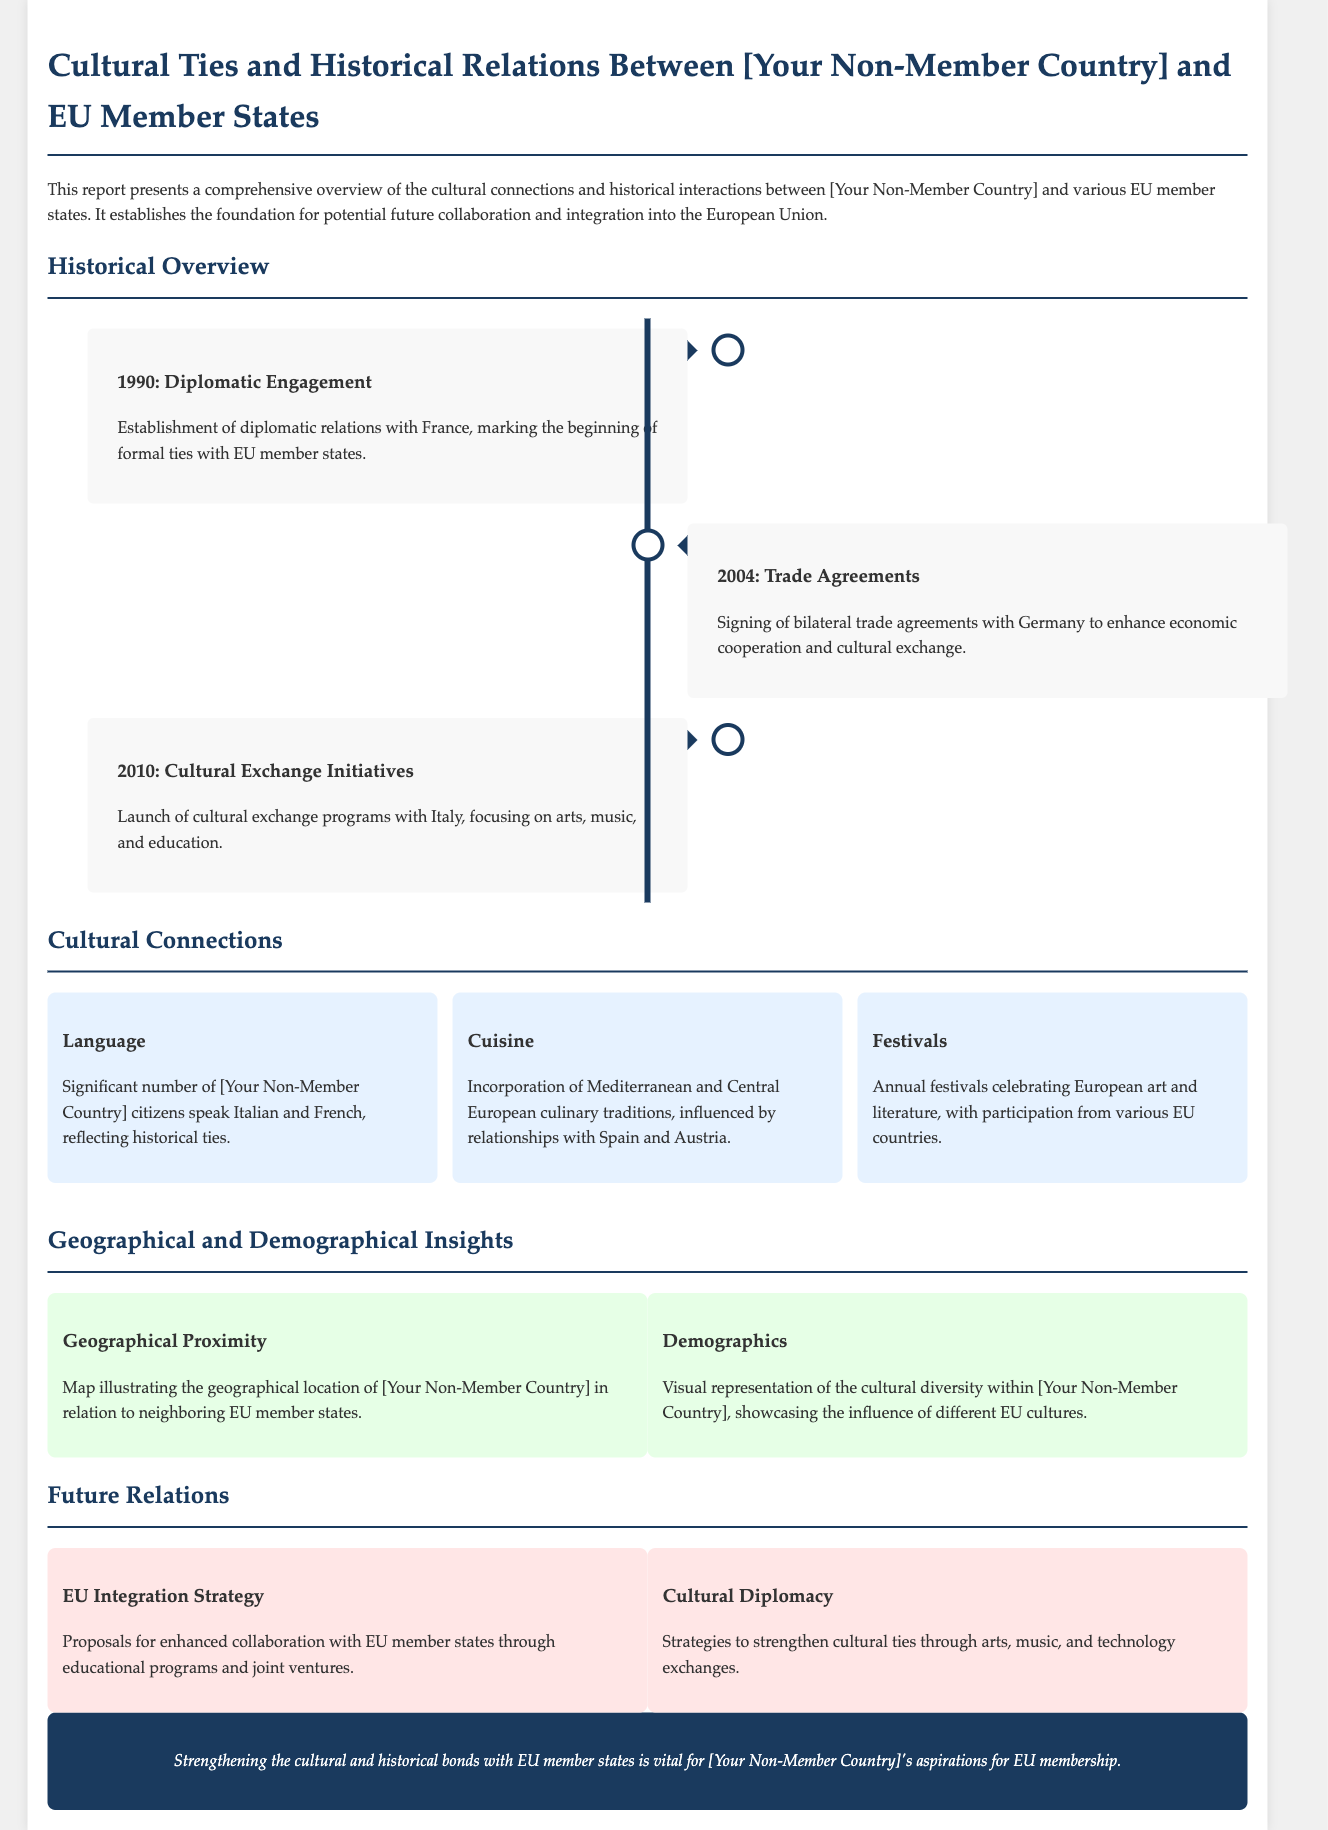What year did diplomatic relations with France begin? The report states that the establishment of diplomatic relations with France occurred in 1990.
Answer: 1990 Which country was involved in the 2004 trade agreements? The document mentions that bilateral trade agreements were signed with Germany in 2004.
Answer: Germany What cultural exchange programs were launched in 2010? The report describes the launch of cultural exchange programs with Italy focusing on arts, music, and education.
Answer: Italy How many cultural connections are highlighted in the document? The document lists three cultural connections: Language, Cuisine, and Festivals.
Answer: Three What is one type of future relation proposed for EU integration? The report suggests enhancing collaboration through educational programs as part of the EU integration strategy.
Answer: Educational programs What influence is seen in the cuisine of the non-member country? The document notes the incorporation of Mediterranean and Central European culinary traditions, influenced by Spain and Austria.
Answer: Spain and Austria What color is used for the conclusion section? The conclusion section is styled with a background color of dark blue indicated by the color code used in the CSS.
Answer: Dark blue How is cultural diversity represented in the report? The document provides a visual representation of cultural diversity showcasing the influence of different EU cultures.
Answer: Visual representation 